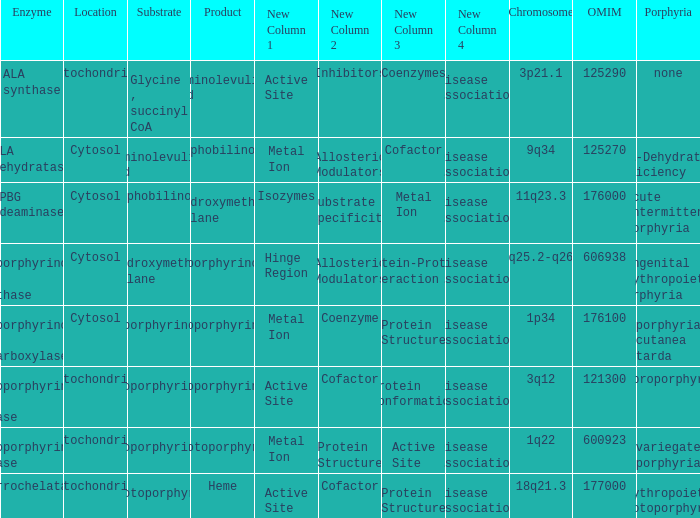Which substrate has an OMIM of 176000? Porphobilinogen. 